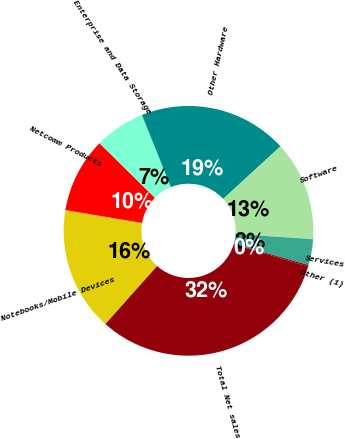Convert chart. <chart><loc_0><loc_0><loc_500><loc_500><pie_chart><fcel>Notebooks/Mobile Devices<fcel>Netcomm Products<fcel>Enterprise and Data Storage<fcel>Other Hardware<fcel>Software<fcel>Services<fcel>Other (1)<fcel>Total Net sales<nl><fcel>16.08%<fcel>9.72%<fcel>6.54%<fcel>19.26%<fcel>12.9%<fcel>3.36%<fcel>0.18%<fcel>31.98%<nl></chart> 